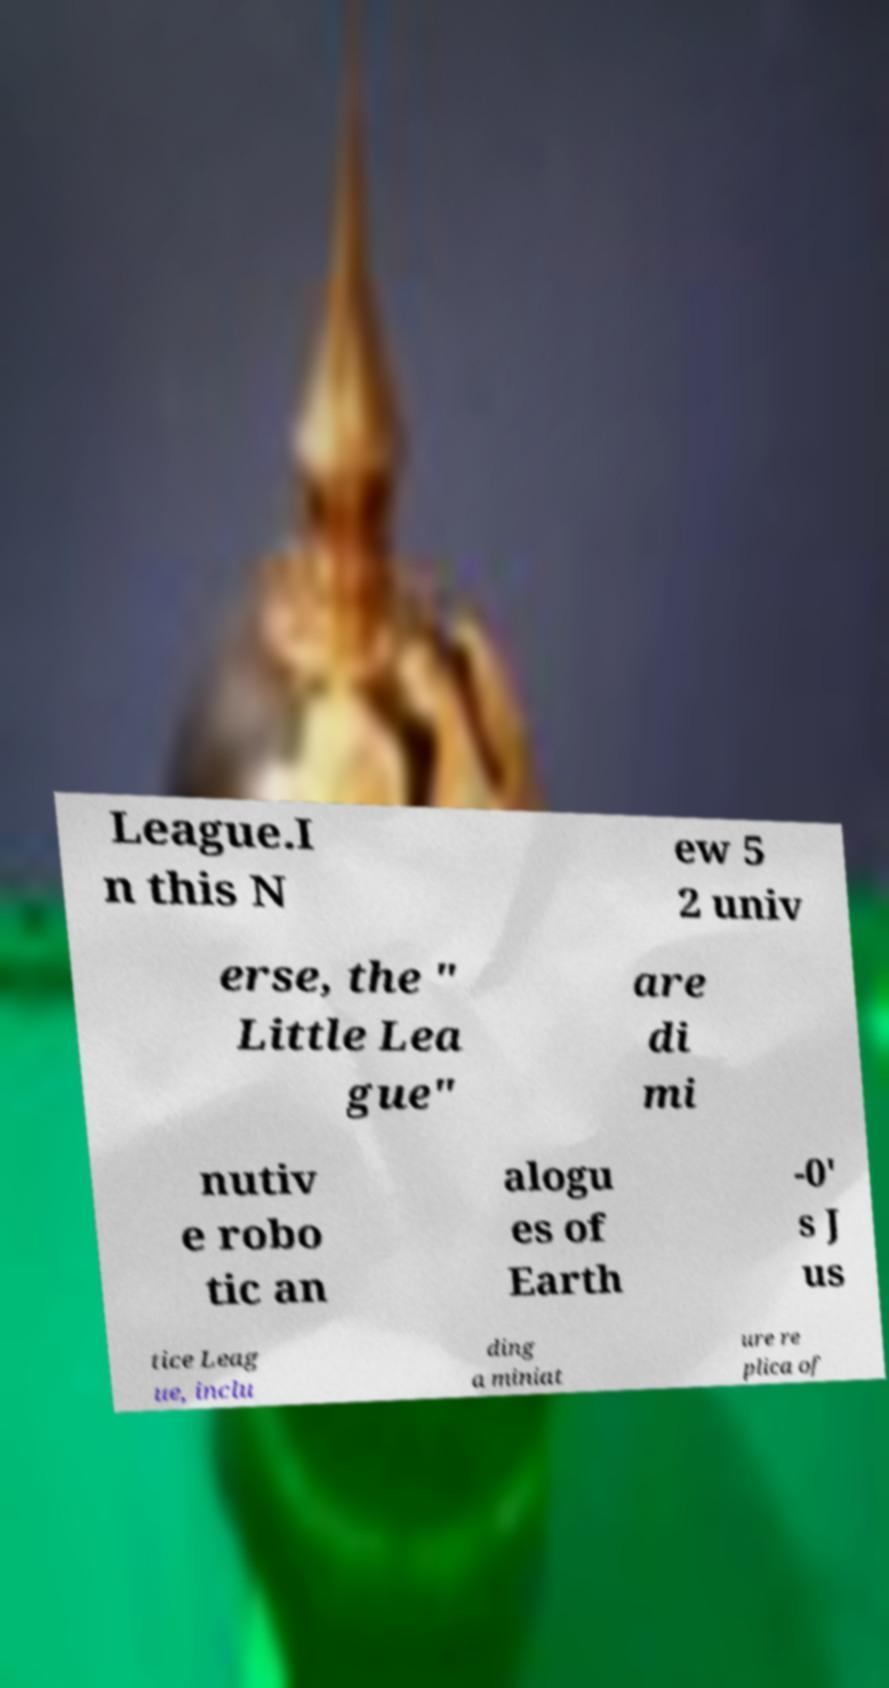Please identify and transcribe the text found in this image. League.I n this N ew 5 2 univ erse, the " Little Lea gue" are di mi nutiv e robo tic an alogu es of Earth -0' s J us tice Leag ue, inclu ding a miniat ure re plica of 